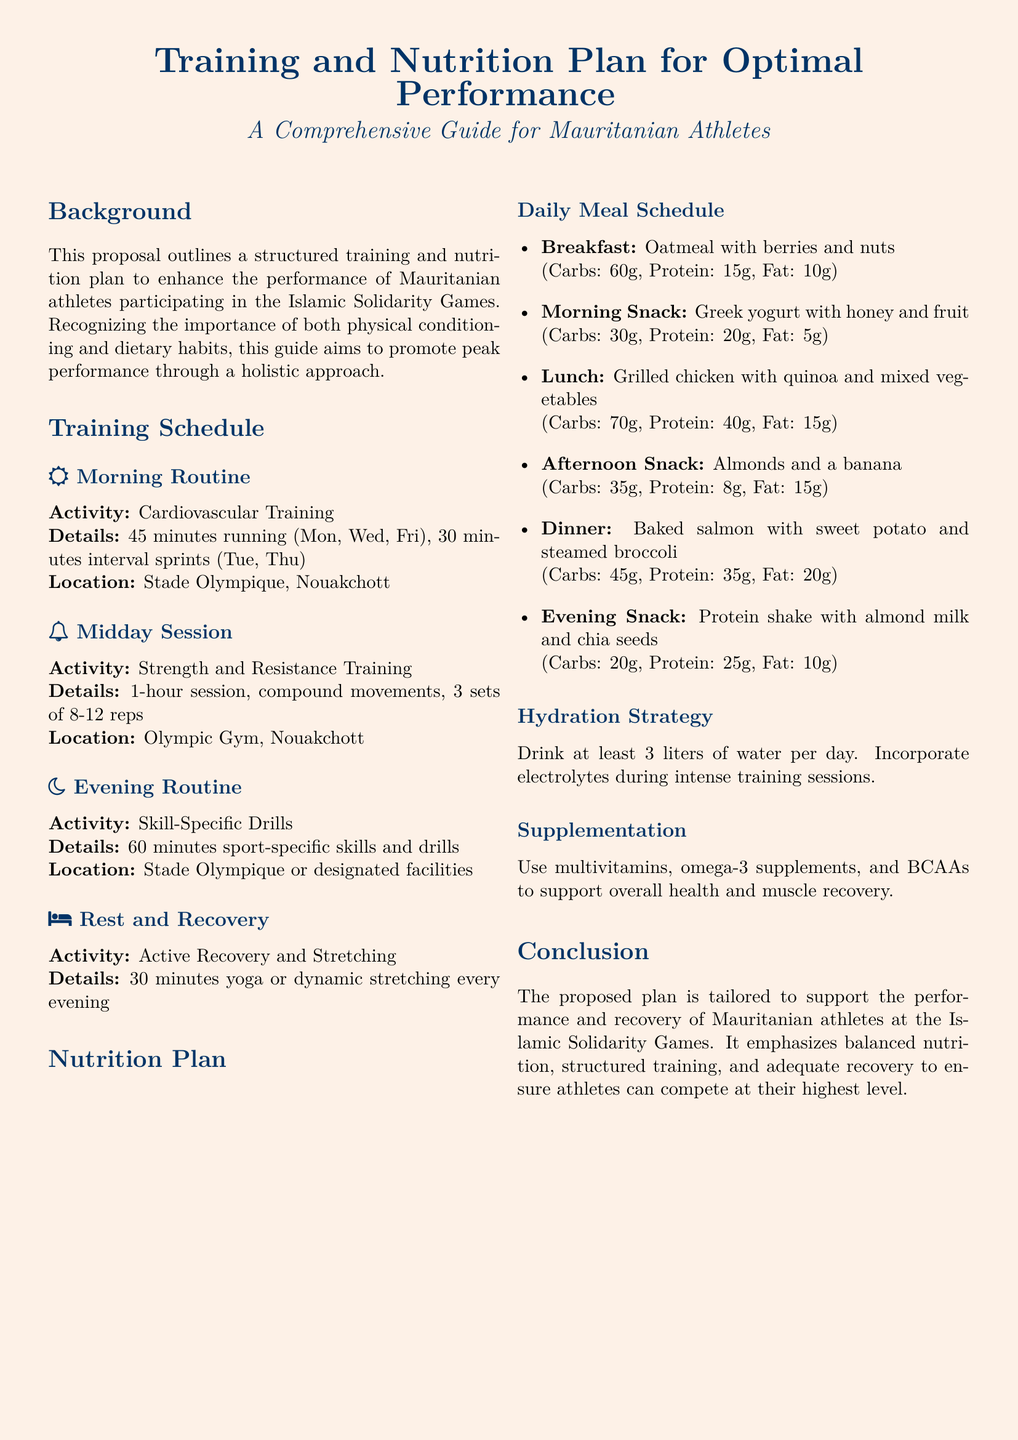What is the main focus of the proposal? The proposal outlines a structured training and nutrition plan aimed at enhancing the performance of Mauritanian athletes participating in the Islamic Solidarity Games.
Answer: Training and nutrition plan How often should athletes perform cardiovascular training? The document states that cardiovascular training should be performed three times a week.
Answer: Three times a week What type of training is included in the midday session? The midday session consists of strength and resistance training.
Answer: Strength and resistance training What is the suggested evening snack? The proposal includes a protein shake with almond milk and chia seeds as the evening snack.
Answer: Protein shake with almond milk and chia seeds How many liters of water should athletes drink daily? The document specifies that athletes should drink at least three liters of water each day.
Answer: Three liters What is the purpose of incorporating electrolytes? Electrolytes are suggested during intense training sessions to help maintain hydration.
Answer: Maintain hydration What strength training format is outlined in the proposal? The strength training format includes compound movements, performing three sets of eight to twelve reps.
Answer: Compound movements, 3 sets of 8-12 reps What kind of recovery activity is recommended in the evening? The proposal recommends active recovery and stretching as an evening activity.
Answer: Active recovery and stretching Which supplements are suggested for health and recovery? The document mentions multivitamins, omega-3 supplements, and BCAAs as suggested supplements.
Answer: Multivitamins, omega-3 supplements, BCAAs 